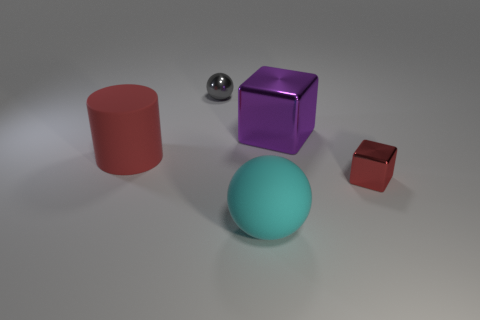Add 5 tiny gray objects. How many objects exist? 10 Subtract all cylinders. How many objects are left? 4 Subtract all rubber things. Subtract all tiny yellow cubes. How many objects are left? 3 Add 4 big cylinders. How many big cylinders are left? 5 Add 2 large purple objects. How many large purple objects exist? 3 Subtract 0 yellow cylinders. How many objects are left? 5 